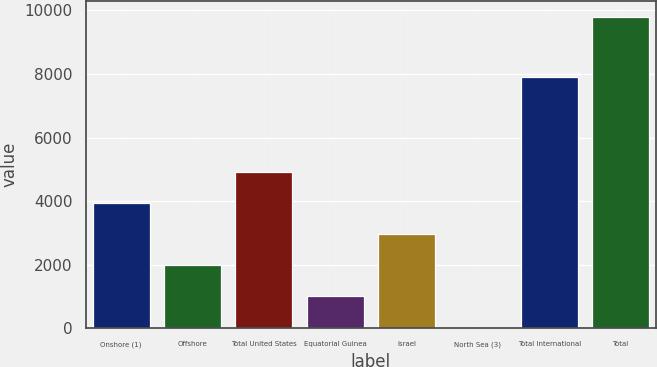Convert chart. <chart><loc_0><loc_0><loc_500><loc_500><bar_chart><fcel>Onshore (1)<fcel>Offshore<fcel>Total United States<fcel>Equatorial Guinea<fcel>Israel<fcel>North Sea (3)<fcel>Total International<fcel>Total<nl><fcel>3933.8<fcel>1979.4<fcel>4911<fcel>1002.2<fcel>2956.6<fcel>25<fcel>7912<fcel>9797<nl></chart> 